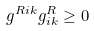Convert formula to latex. <formula><loc_0><loc_0><loc_500><loc_500>g ^ { R i k } g _ { i k } ^ { R } \geq 0</formula> 